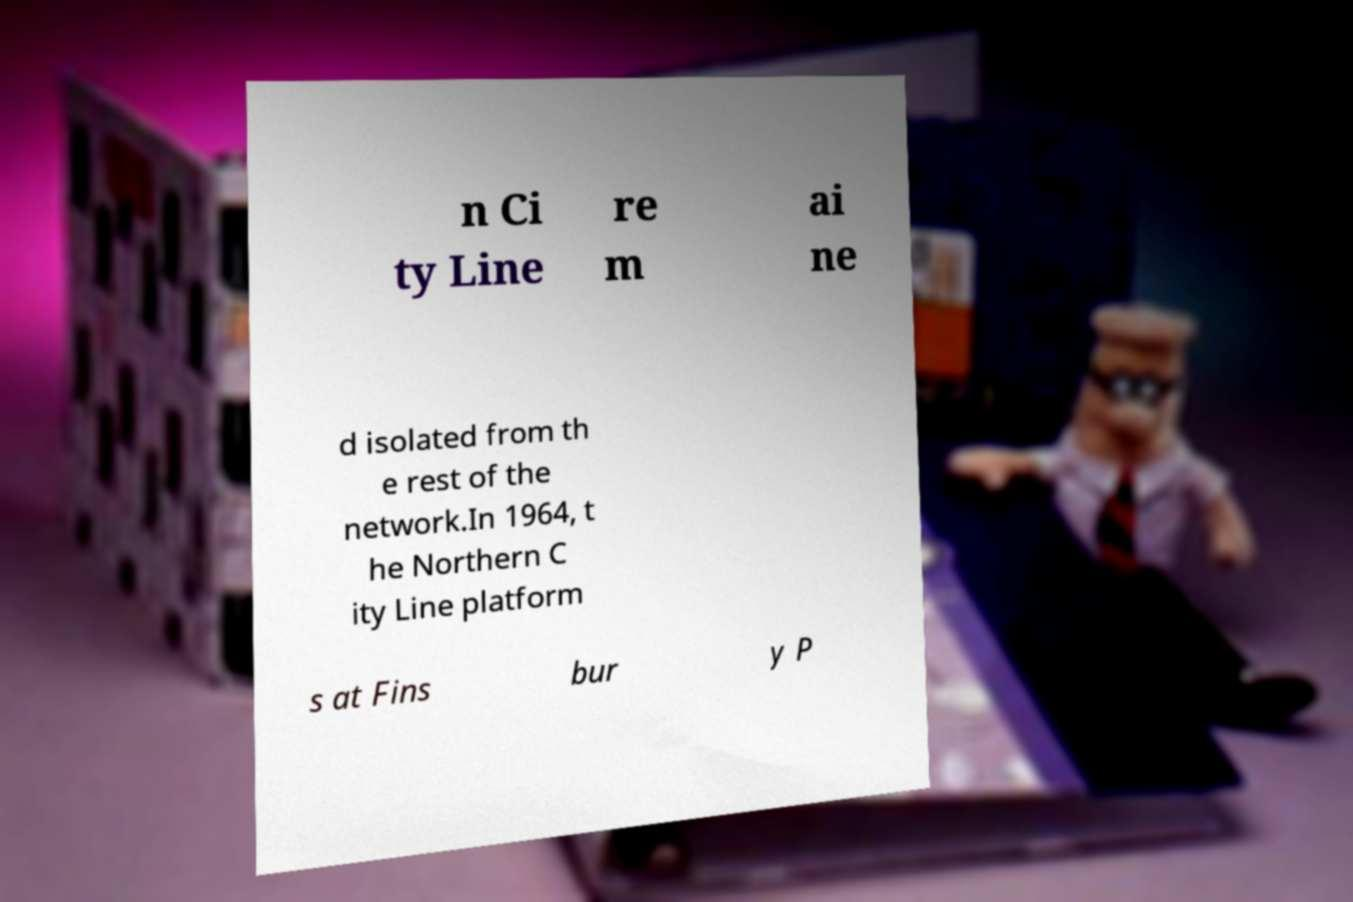Please read and relay the text visible in this image. What does it say? n Ci ty Line re m ai ne d isolated from th e rest of the network.In 1964, t he Northern C ity Line platform s at Fins bur y P 